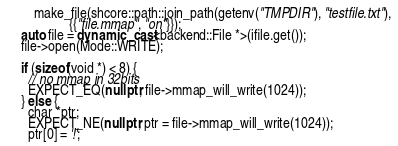<code> <loc_0><loc_0><loc_500><loc_500><_C++_>        make_file(shcore::path::join_path(getenv("TMPDIR"), "testfile.txt"),
                  {{"file.mmap", "on"}});
    auto file = dynamic_cast<backend::File *>(ifile.get());
    file->open(Mode::WRITE);

    if (sizeof(void *) < 8) {
      // no mmap in 32bits
      EXPECT_EQ(nullptr, file->mmap_will_write(1024));
    } else {
      char *ptr;
      EXPECT_NE(nullptr, ptr = file->mmap_will_write(1024));
      ptr[0] = '!';</code> 